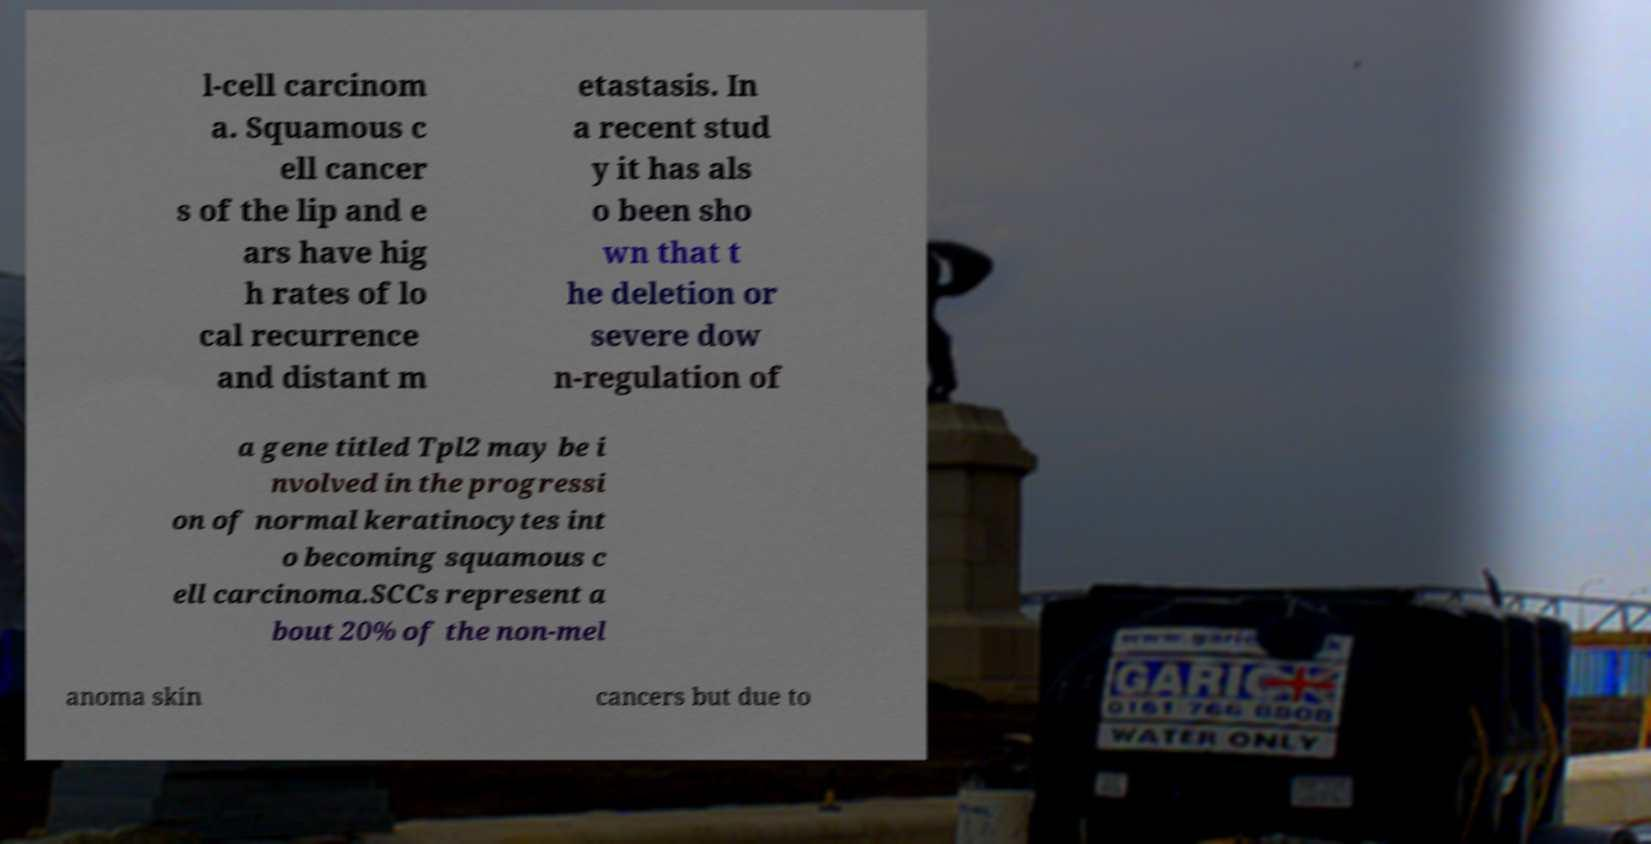Can you read and provide the text displayed in the image?This photo seems to have some interesting text. Can you extract and type it out for me? l-cell carcinom a. Squamous c ell cancer s of the lip and e ars have hig h rates of lo cal recurrence and distant m etastasis. In a recent stud y it has als o been sho wn that t he deletion or severe dow n-regulation of a gene titled Tpl2 may be i nvolved in the progressi on of normal keratinocytes int o becoming squamous c ell carcinoma.SCCs represent a bout 20% of the non-mel anoma skin cancers but due to 